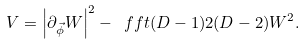<formula> <loc_0><loc_0><loc_500><loc_500>V = \left | \partial _ { \vec { \phi } } W \right | ^ { 2 } - \ f f t { ( D - 1 ) } { 2 ( D - 2 ) } W ^ { 2 } .</formula> 